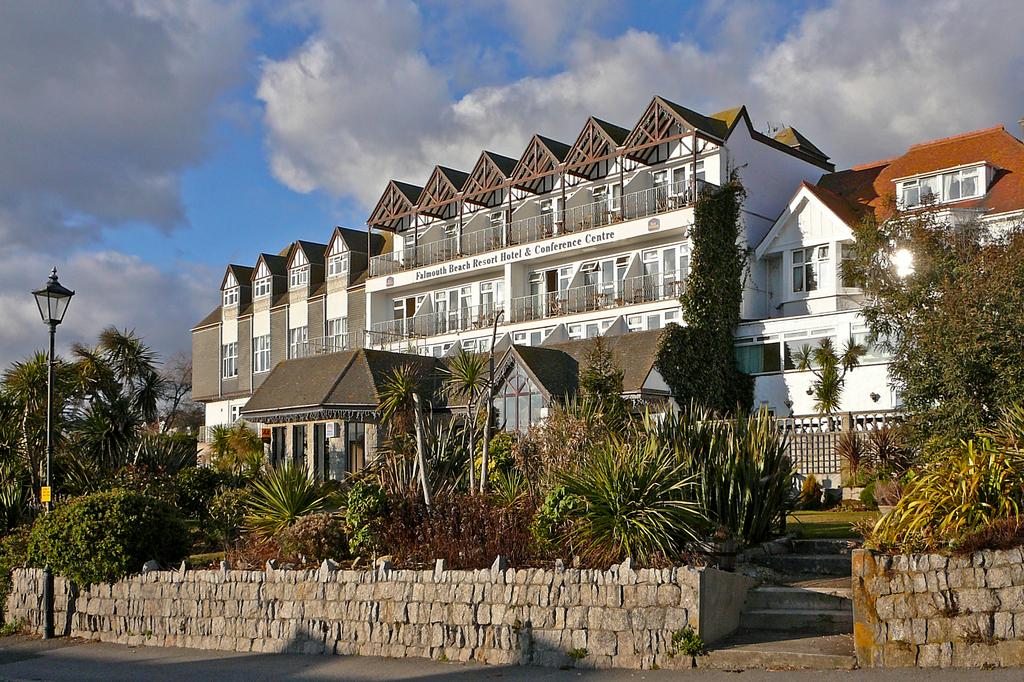What is attached to the pole in the image? There is a light attached to the pole in the image. What can be seen on the right side of the pole? There are plants, trees, a wall, and buildings on the right side of the pole. What is visible behind the buildings? The sky is visible behind the buildings. In which direction does the pole face in the image? The direction the pole faces cannot be determined from the image. How does the pole breathe in the image? The pole does not breathe in the image; it is an inanimate object. 